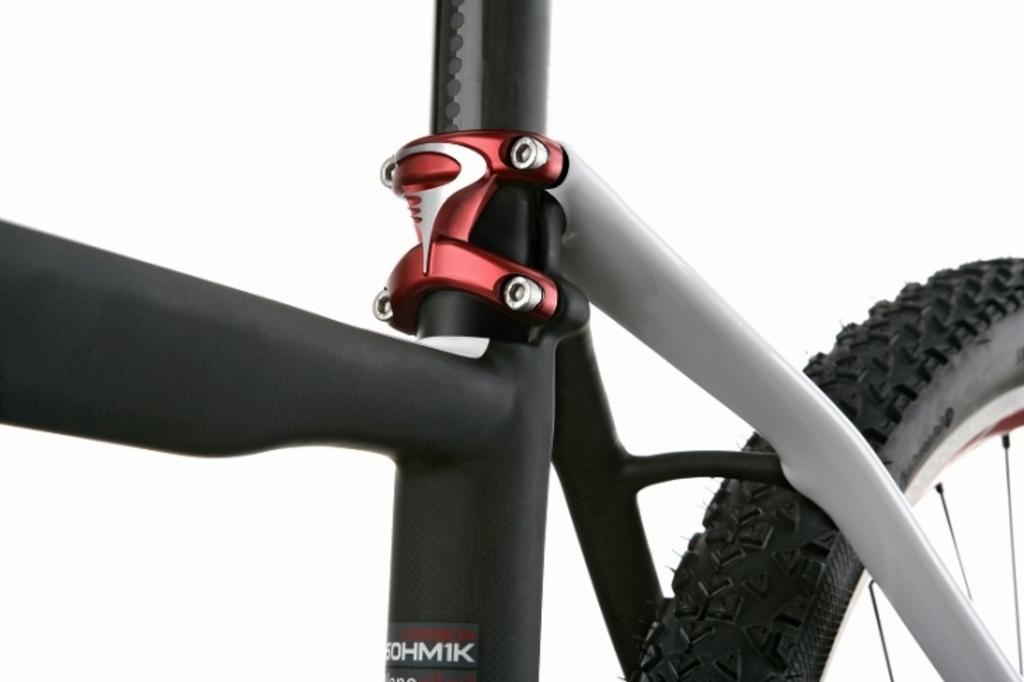What is the main subject of the image? The main subject of the image is a bicycle. Where is the bicycle located in the image? The bicycle is in the center of the image. What type of owl can be seen sitting on the handlebars of the bicycle in the image? There is no owl present in the image; it only features a bicycle. 